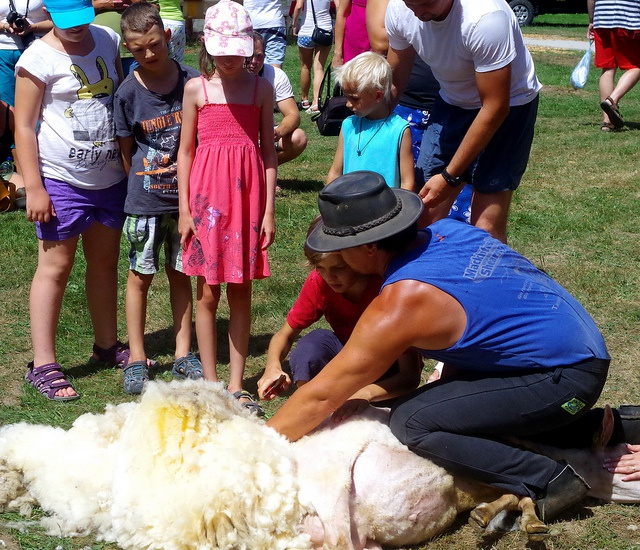Describe the objects in this image and their specific colors. I can see people in white, black, maroon, gray, and lavender tones, sheep in white, ivory, tan, and darkgray tones, sheep in white, tan, gray, and maroon tones, people in white, black, maroon, purple, and brown tones, and people in white, lightblue, cyan, maroon, and black tones in this image. 